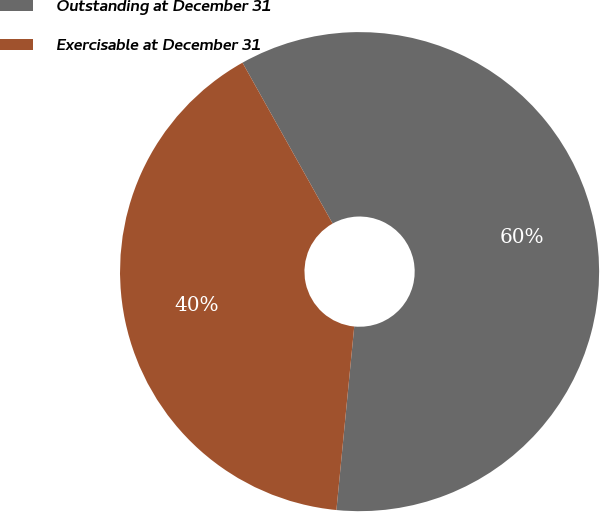<chart> <loc_0><loc_0><loc_500><loc_500><pie_chart><fcel>Outstanding at December 31<fcel>Exercisable at December 31<nl><fcel>59.67%<fcel>40.33%<nl></chart> 